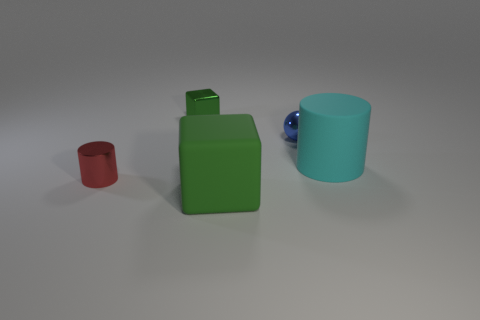Are there any big blocks of the same color as the tiny metallic cube?
Your answer should be very brief. Yes. How many other things are the same shape as the blue object?
Keep it short and to the point. 0. There is a rubber thing behind the small metallic cylinder; what is its shape?
Your answer should be very brief. Cylinder. There is a tiny green object; is its shape the same as the large object on the left side of the small blue ball?
Give a very brief answer. Yes. How big is the object that is on the right side of the metal cylinder and to the left of the large cube?
Provide a short and direct response. Small. What color is the object that is both behind the small red cylinder and in front of the small blue ball?
Provide a succinct answer. Cyan. Is the number of small green shiny things that are right of the rubber cylinder less than the number of big green cubes that are on the right side of the tiny shiny block?
Your answer should be compact. Yes. Is there anything else of the same color as the tiny cylinder?
Provide a succinct answer. No. What is the shape of the large cyan thing?
Your answer should be compact. Cylinder. What is the color of the object that is the same material as the large cube?
Offer a terse response. Cyan. 